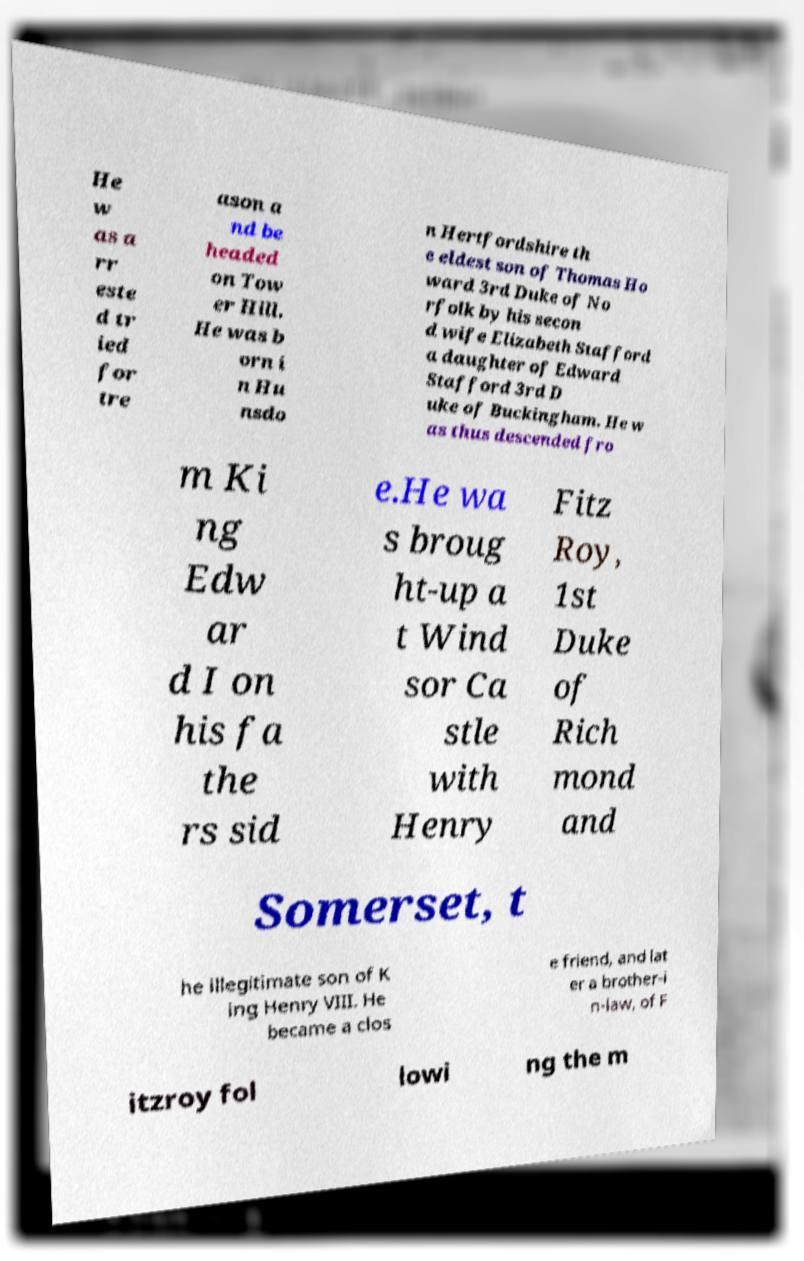Can you read and provide the text displayed in the image?This photo seems to have some interesting text. Can you extract and type it out for me? He w as a rr este d tr ied for tre ason a nd be headed on Tow er Hill. He was b orn i n Hu nsdo n Hertfordshire th e eldest son of Thomas Ho ward 3rd Duke of No rfolk by his secon d wife Elizabeth Stafford a daughter of Edward Stafford 3rd D uke of Buckingham. He w as thus descended fro m Ki ng Edw ar d I on his fa the rs sid e.He wa s broug ht-up a t Wind sor Ca stle with Henry Fitz Roy, 1st Duke of Rich mond and Somerset, t he illegitimate son of K ing Henry VIII. He became a clos e friend, and lat er a brother-i n-law, of F itzroy fol lowi ng the m 